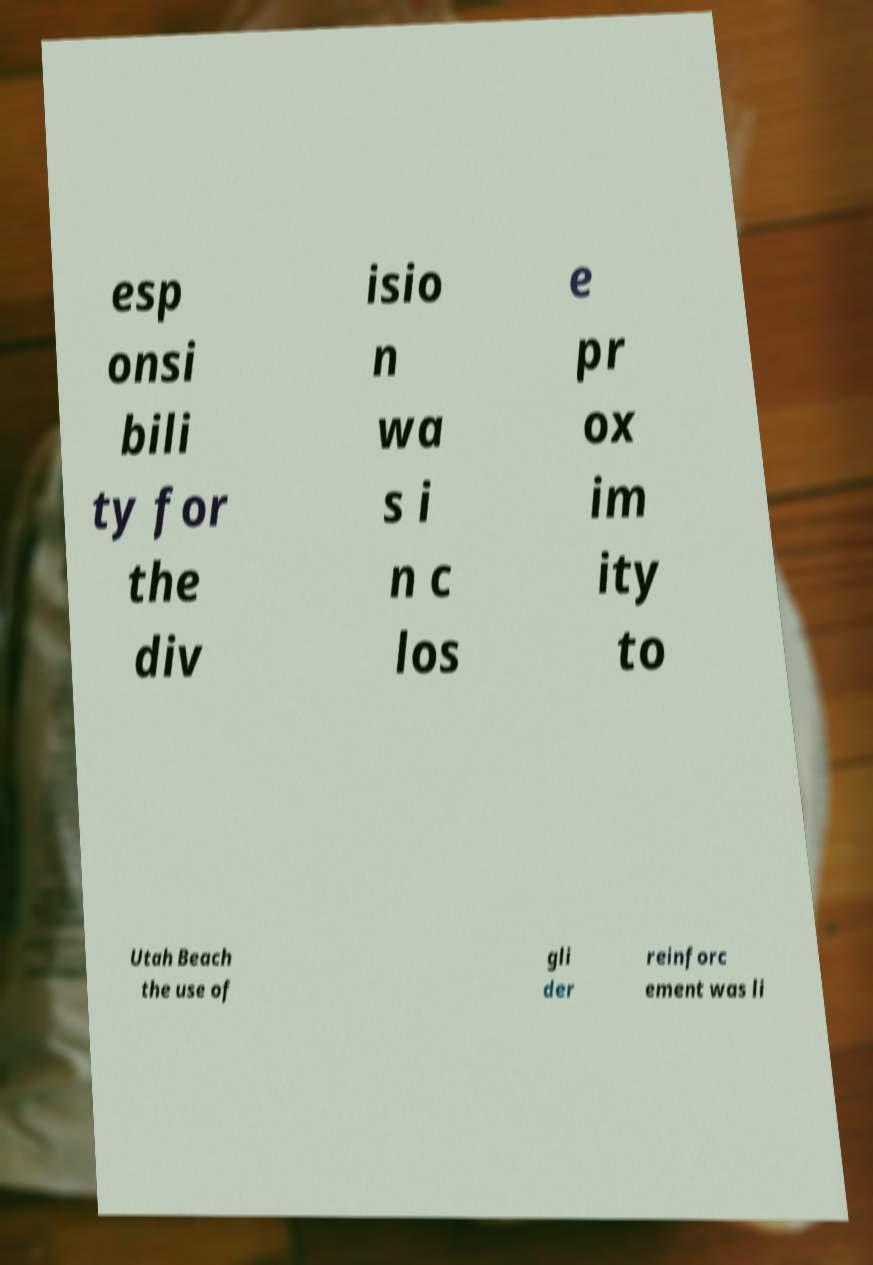Could you assist in decoding the text presented in this image and type it out clearly? esp onsi bili ty for the div isio n wa s i n c los e pr ox im ity to Utah Beach the use of gli der reinforc ement was li 